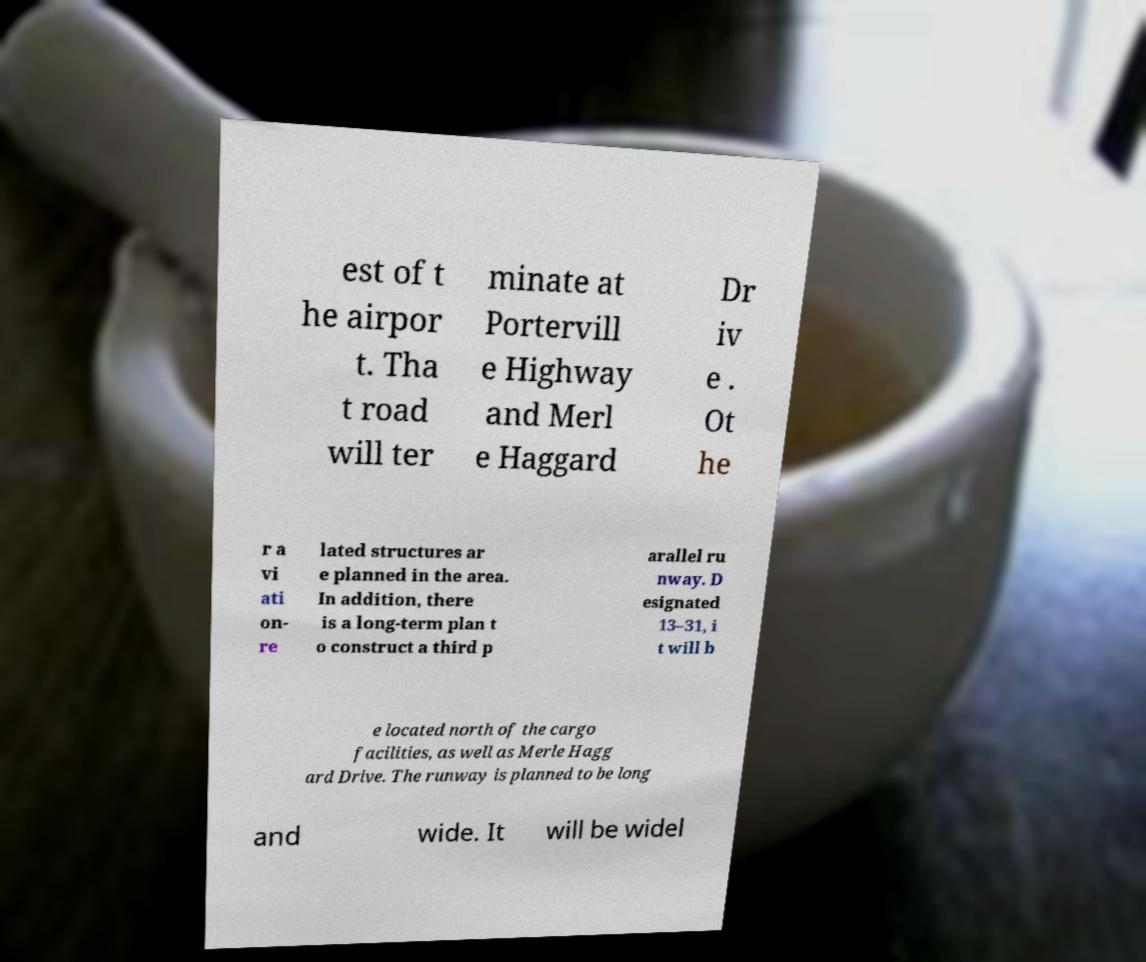I need the written content from this picture converted into text. Can you do that? est of t he airpor t. Tha t road will ter minate at Portervill e Highway and Merl e Haggard Dr iv e . Ot he r a vi ati on- re lated structures ar e planned in the area. In addition, there is a long-term plan t o construct a third p arallel ru nway. D esignated 13–31, i t will b e located north of the cargo facilities, as well as Merle Hagg ard Drive. The runway is planned to be long and wide. It will be widel 